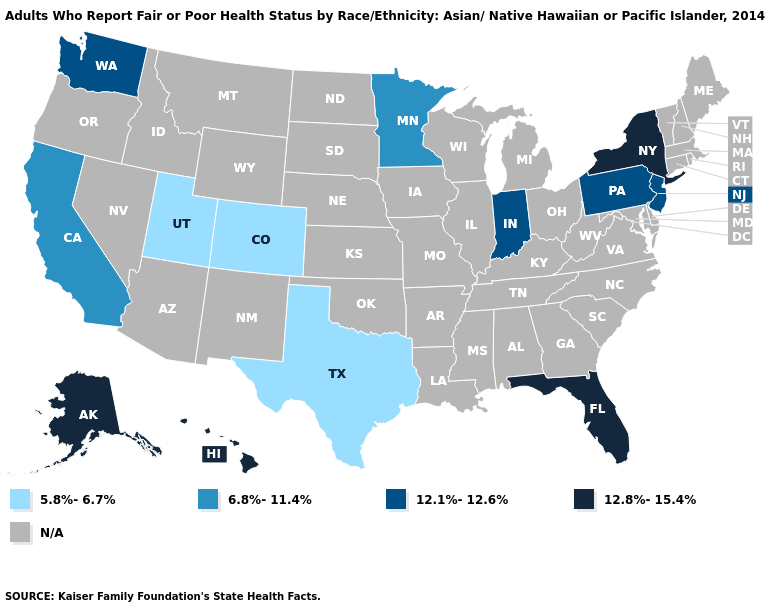Which states have the highest value in the USA?
Short answer required. Alaska, Florida, Hawaii, New York. What is the highest value in the MidWest ?
Be succinct. 12.1%-12.6%. Name the states that have a value in the range N/A?
Be succinct. Alabama, Arizona, Arkansas, Connecticut, Delaware, Georgia, Idaho, Illinois, Iowa, Kansas, Kentucky, Louisiana, Maine, Maryland, Massachusetts, Michigan, Mississippi, Missouri, Montana, Nebraska, Nevada, New Hampshire, New Mexico, North Carolina, North Dakota, Ohio, Oklahoma, Oregon, Rhode Island, South Carolina, South Dakota, Tennessee, Vermont, Virginia, West Virginia, Wisconsin, Wyoming. Name the states that have a value in the range N/A?
Be succinct. Alabama, Arizona, Arkansas, Connecticut, Delaware, Georgia, Idaho, Illinois, Iowa, Kansas, Kentucky, Louisiana, Maine, Maryland, Massachusetts, Michigan, Mississippi, Missouri, Montana, Nebraska, Nevada, New Hampshire, New Mexico, North Carolina, North Dakota, Ohio, Oklahoma, Oregon, Rhode Island, South Carolina, South Dakota, Tennessee, Vermont, Virginia, West Virginia, Wisconsin, Wyoming. Which states have the lowest value in the Northeast?
Concise answer only. New Jersey, Pennsylvania. Name the states that have a value in the range N/A?
Be succinct. Alabama, Arizona, Arkansas, Connecticut, Delaware, Georgia, Idaho, Illinois, Iowa, Kansas, Kentucky, Louisiana, Maine, Maryland, Massachusetts, Michigan, Mississippi, Missouri, Montana, Nebraska, Nevada, New Hampshire, New Mexico, North Carolina, North Dakota, Ohio, Oklahoma, Oregon, Rhode Island, South Carolina, South Dakota, Tennessee, Vermont, Virginia, West Virginia, Wisconsin, Wyoming. Name the states that have a value in the range 12.1%-12.6%?
Give a very brief answer. Indiana, New Jersey, Pennsylvania, Washington. What is the value of Pennsylvania?
Keep it brief. 12.1%-12.6%. Is the legend a continuous bar?
Write a very short answer. No. Name the states that have a value in the range 12.1%-12.6%?
Short answer required. Indiana, New Jersey, Pennsylvania, Washington. Is the legend a continuous bar?
Quick response, please. No. What is the value of Hawaii?
Write a very short answer. 12.8%-15.4%. What is the value of Mississippi?
Keep it brief. N/A. What is the value of Ohio?
Concise answer only. N/A. Which states have the lowest value in the West?
Keep it brief. Colorado, Utah. 